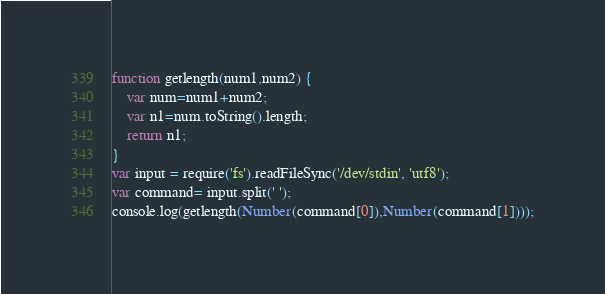<code> <loc_0><loc_0><loc_500><loc_500><_JavaScript_>function getlength(num1,num2) {
    var num=num1+num2;
    var n1=num.toString().length;
    return n1;
}
var input = require('fs').readFileSync('/dev/stdin', 'utf8');
var command= input.split(' ');
console.log(getlength(Number(command[0]),Number(command[1])));</code> 